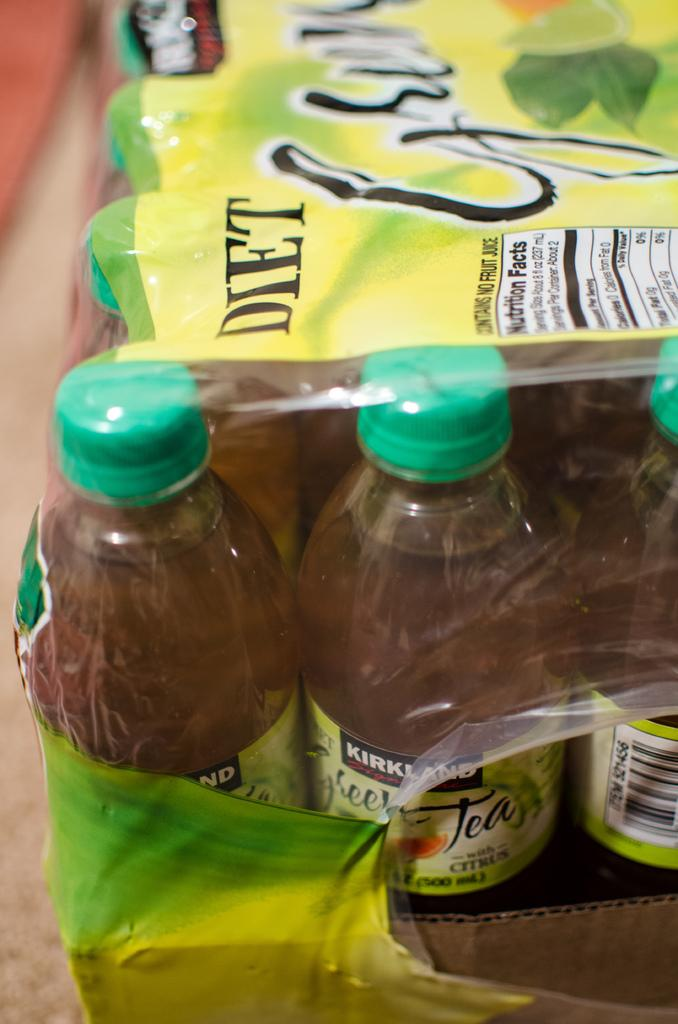Provide a one-sentence caption for the provided image. A case of diet sweet tea that is Kirkland brand. 